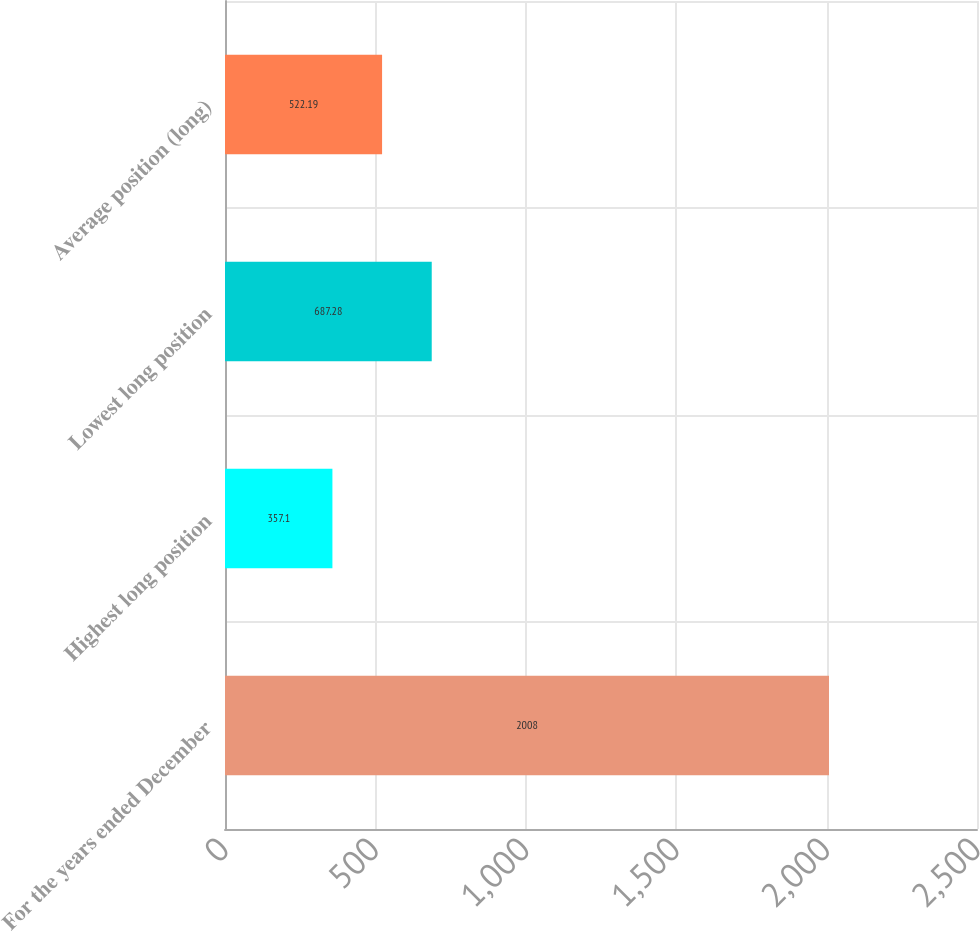Convert chart. <chart><loc_0><loc_0><loc_500><loc_500><bar_chart><fcel>For the years ended December<fcel>Highest long position<fcel>Lowest long position<fcel>Average position (long)<nl><fcel>2008<fcel>357.1<fcel>687.28<fcel>522.19<nl></chart> 